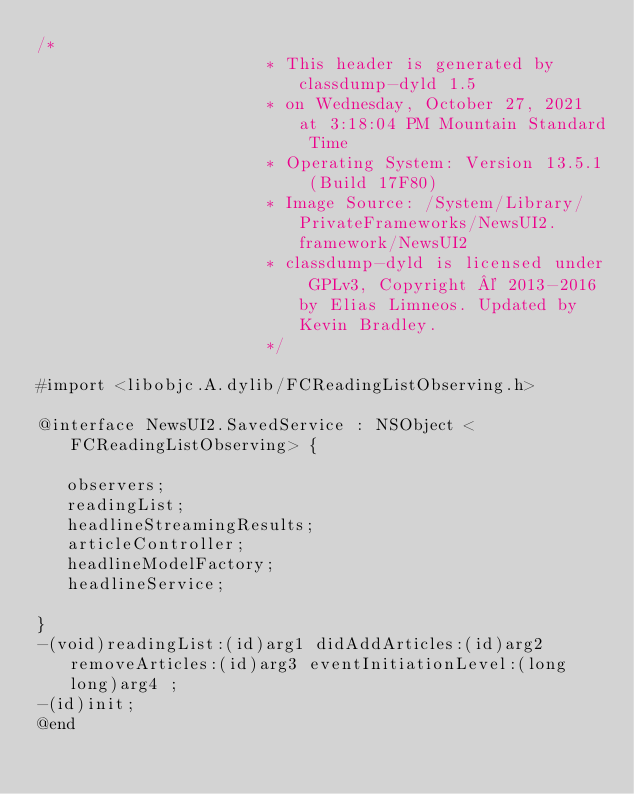<code> <loc_0><loc_0><loc_500><loc_500><_C_>/*
                       * This header is generated by classdump-dyld 1.5
                       * on Wednesday, October 27, 2021 at 3:18:04 PM Mountain Standard Time
                       * Operating System: Version 13.5.1 (Build 17F80)
                       * Image Source: /System/Library/PrivateFrameworks/NewsUI2.framework/NewsUI2
                       * classdump-dyld is licensed under GPLv3, Copyright © 2013-2016 by Elias Limneos. Updated by Kevin Bradley.
                       */

#import <libobjc.A.dylib/FCReadingListObserving.h>

@interface NewsUI2.SavedService : NSObject <FCReadingListObserving> {

	 observers;
	 readingList;
	 headlineStreamingResults;
	 articleController;
	 headlineModelFactory;
	 headlineService;

}
-(void)readingList:(id)arg1 didAddArticles:(id)arg2 removeArticles:(id)arg3 eventInitiationLevel:(long long)arg4 ;
-(id)init;
@end

</code> 